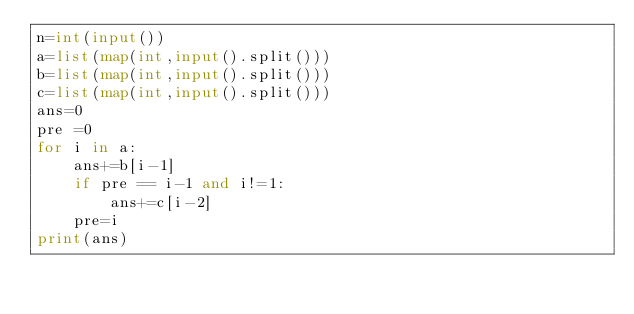Convert code to text. <code><loc_0><loc_0><loc_500><loc_500><_Python_>n=int(input())
a=list(map(int,input().split()))
b=list(map(int,input().split()))
c=list(map(int,input().split()))
ans=0
pre =0
for i in a:
    ans+=b[i-1]
    if pre == i-1 and i!=1:
        ans+=c[i-2]
    pre=i
print(ans)

</code> 